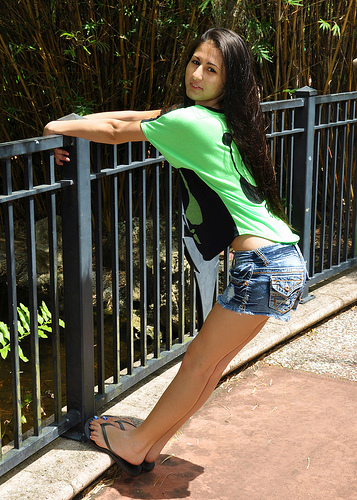<image>
Can you confirm if the girl is on the bamboo grass? No. The girl is not positioned on the bamboo grass. They may be near each other, but the girl is not supported by or resting on top of the bamboo grass. 